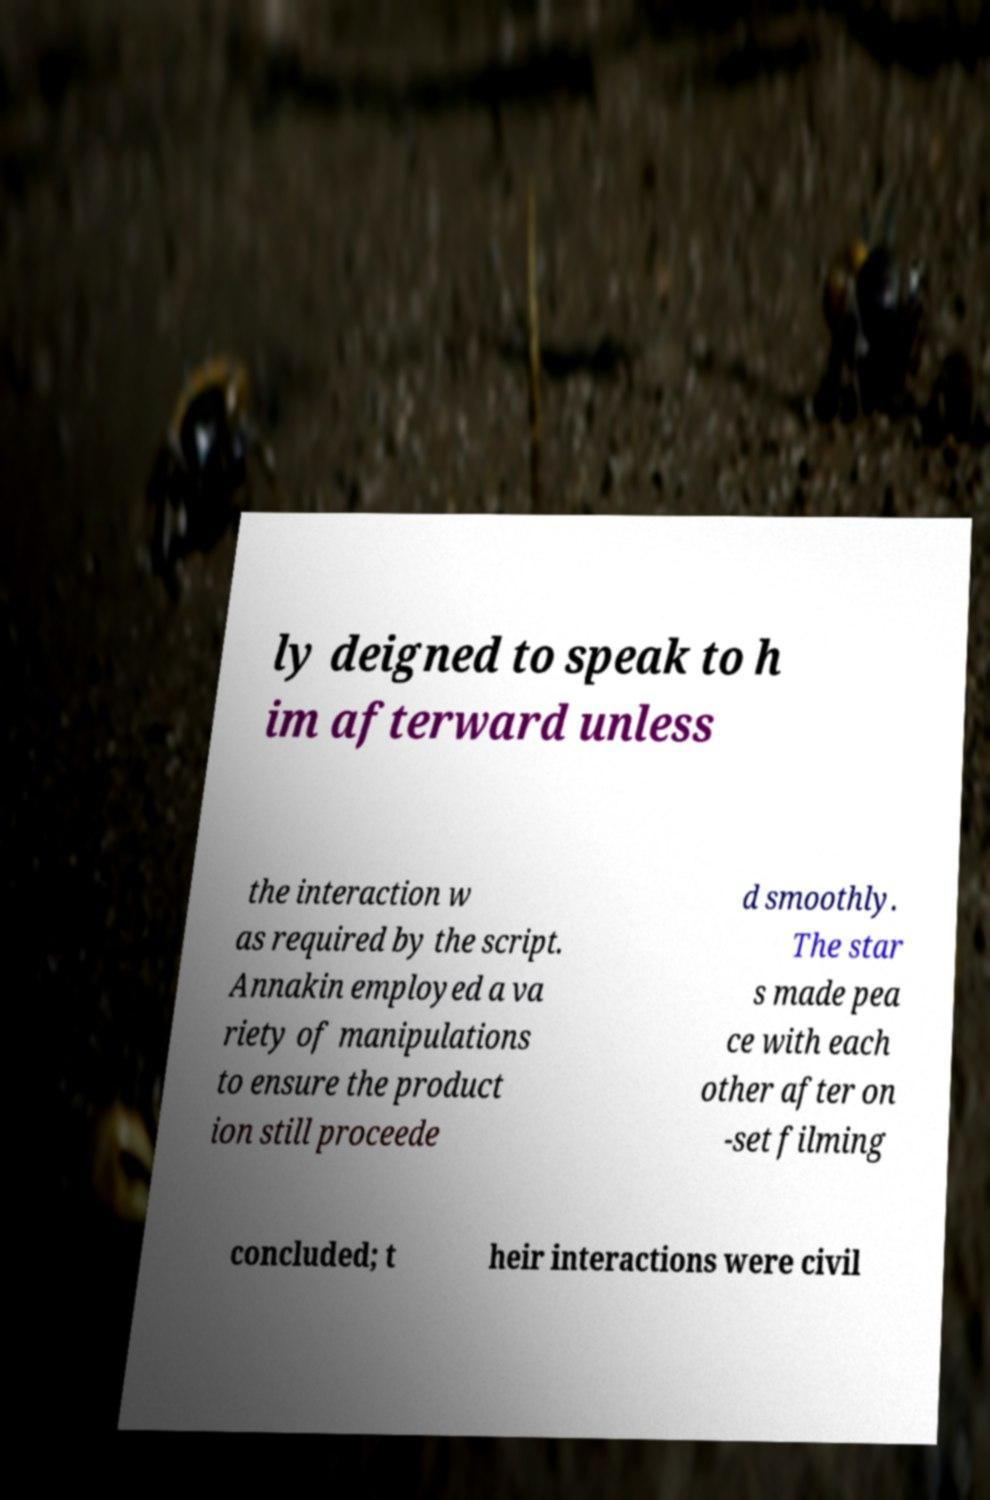Could you extract and type out the text from this image? ly deigned to speak to h im afterward unless the interaction w as required by the script. Annakin employed a va riety of manipulations to ensure the product ion still proceede d smoothly. The star s made pea ce with each other after on -set filming concluded; t heir interactions were civil 